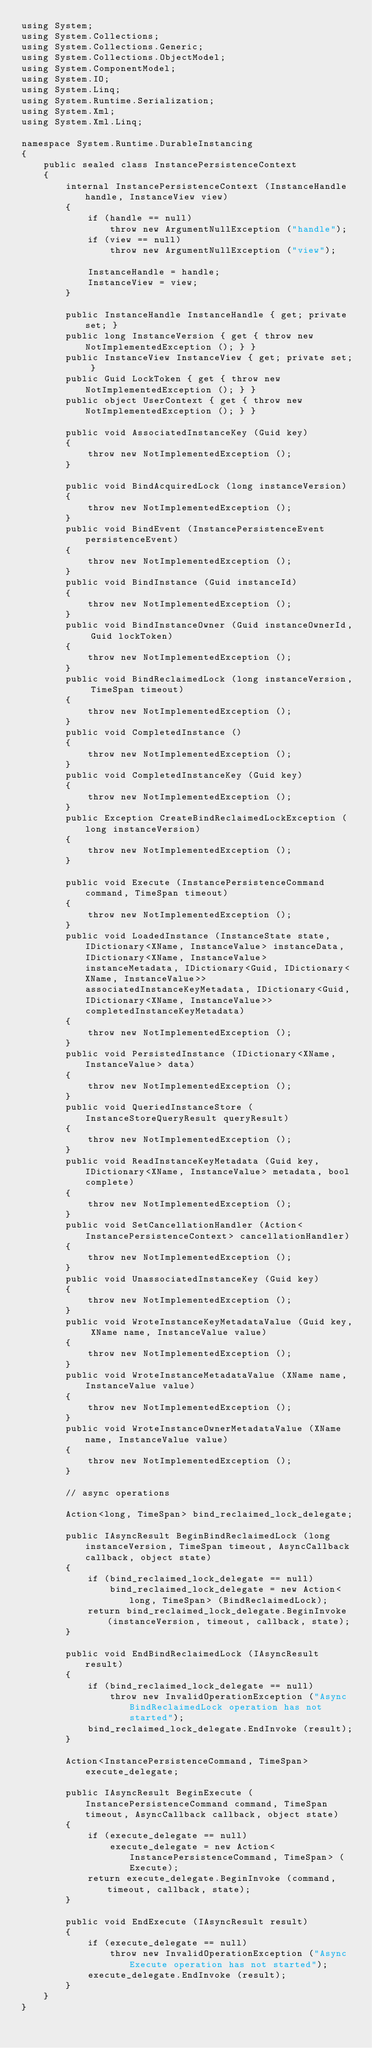<code> <loc_0><loc_0><loc_500><loc_500><_C#_>using System;
using System.Collections;
using System.Collections.Generic;
using System.Collections.ObjectModel;
using System.ComponentModel;
using System.IO;
using System.Linq;
using System.Runtime.Serialization;
using System.Xml;
using System.Xml.Linq;

namespace System.Runtime.DurableInstancing
{
	public sealed class InstancePersistenceContext
	{
		internal InstancePersistenceContext (InstanceHandle handle, InstanceView view)
		{
			if (handle == null)
				throw new ArgumentNullException ("handle");
			if (view == null)
				throw new ArgumentNullException ("view");

			InstanceHandle = handle;
			InstanceView = view;
		}
		
		public InstanceHandle InstanceHandle { get; private set; }
		public long InstanceVersion { get { throw new NotImplementedException (); } }
		public InstanceView InstanceView { get; private set; }
		public Guid LockToken { get { throw new NotImplementedException (); } }
		public object UserContext { get { throw new NotImplementedException (); } }

		public void AssociatedInstanceKey (Guid key)
		{
			throw new NotImplementedException ();
		}

		public void BindAcquiredLock (long instanceVersion)
		{
			throw new NotImplementedException ();
		}
		public void BindEvent (InstancePersistenceEvent persistenceEvent)
		{
			throw new NotImplementedException ();
		}
		public void BindInstance (Guid instanceId)
		{
			throw new NotImplementedException ();
		}
		public void BindInstanceOwner (Guid instanceOwnerId, Guid lockToken)
		{
			throw new NotImplementedException ();
		}
		public void BindReclaimedLock (long instanceVersion, TimeSpan timeout)
		{
			throw new NotImplementedException ();
		}
		public void CompletedInstance ()
		{
			throw new NotImplementedException ();
		}
		public void CompletedInstanceKey (Guid key)
		{
			throw new NotImplementedException ();
		}
		public Exception CreateBindReclaimedLockException (long instanceVersion)
		{
			throw new NotImplementedException ();
		}

		public void Execute (InstancePersistenceCommand command, TimeSpan timeout)
		{
			throw new NotImplementedException ();
		}
		public void LoadedInstance (InstanceState state, IDictionary<XName, InstanceValue> instanceData, IDictionary<XName, InstanceValue> instanceMetadata, IDictionary<Guid, IDictionary<XName, InstanceValue>> associatedInstanceKeyMetadata, IDictionary<Guid, IDictionary<XName, InstanceValue>> completedInstanceKeyMetadata)
		{
			throw new NotImplementedException ();
		}
		public void PersistedInstance (IDictionary<XName, InstanceValue> data)
		{
			throw new NotImplementedException ();
		}
		public void QueriedInstanceStore (InstanceStoreQueryResult queryResult)
		{
			throw new NotImplementedException ();
		}
		public void ReadInstanceKeyMetadata (Guid key, IDictionary<XName, InstanceValue> metadata, bool complete)
		{
			throw new NotImplementedException ();
		}
		public void SetCancellationHandler (Action<InstancePersistenceContext> cancellationHandler)
		{
			throw new NotImplementedException ();
		}
		public void UnassociatedInstanceKey (Guid key)
		{
			throw new NotImplementedException ();
		}
		public void WroteInstanceKeyMetadataValue (Guid key, XName name, InstanceValue value)
		{
			throw new NotImplementedException ();
		}
		public void WroteInstanceMetadataValue (XName name, InstanceValue value)
		{
			throw new NotImplementedException ();
		}
		public void WroteInstanceOwnerMetadataValue (XName name, InstanceValue value)
		{
			throw new NotImplementedException ();
		}

		// async operations

		Action<long, TimeSpan> bind_reclaimed_lock_delegate;
		
		public IAsyncResult BeginBindReclaimedLock (long instanceVersion, TimeSpan timeout, AsyncCallback callback, object state)
		{
			if (bind_reclaimed_lock_delegate == null)
				bind_reclaimed_lock_delegate = new Action<long, TimeSpan> (BindReclaimedLock);
			return bind_reclaimed_lock_delegate.BeginInvoke (instanceVersion, timeout, callback, state);
		}

		public void EndBindReclaimedLock (IAsyncResult result)
		{
			if (bind_reclaimed_lock_delegate == null)
				throw new InvalidOperationException ("Async BindReclaimedLock operation has not started");
			bind_reclaimed_lock_delegate.EndInvoke (result);
		}

		Action<InstancePersistenceCommand, TimeSpan> execute_delegate;
		
		public IAsyncResult BeginExecute (InstancePersistenceCommand command, TimeSpan timeout, AsyncCallback callback, object state)
		{
			if (execute_delegate == null)
				execute_delegate = new Action<InstancePersistenceCommand, TimeSpan> (Execute);
			return execute_delegate.BeginInvoke (command, timeout, callback, state);
		}
		
		public void EndExecute (IAsyncResult result)
		{
			if (execute_delegate == null)
				throw new InvalidOperationException ("Async Execute operation has not started");
			execute_delegate.EndInvoke (result);
		}
	}
}
</code> 